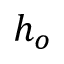Convert formula to latex. <formula><loc_0><loc_0><loc_500><loc_500>h _ { o }</formula> 